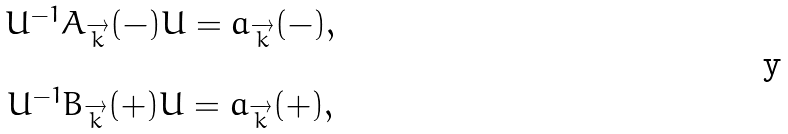<formula> <loc_0><loc_0><loc_500><loc_500>\begin{array} { c } U ^ { - 1 } A _ { \overrightarrow { k } } ( - ) U = a _ { \overrightarrow { k } } ( - ) , \\ \\ U ^ { - 1 } B _ { \overrightarrow { k } } ( + ) U = a _ { \overrightarrow { k } } ( + ) , \end{array}</formula> 